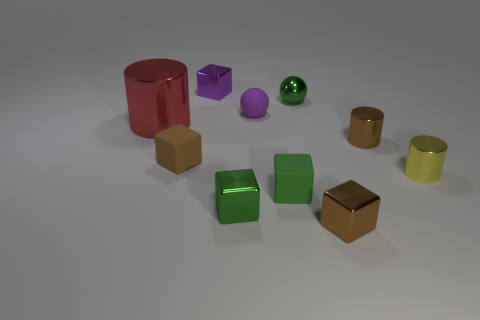There is a big cylinder that is to the left of the yellow shiny thing; are there any small matte objects on the left side of it?
Keep it short and to the point. No. Is there any other thing that is the same material as the tiny yellow cylinder?
Give a very brief answer. Yes. There is a brown matte object; is it the same shape as the green thing behind the small yellow metal object?
Give a very brief answer. No. How many other objects are there of the same size as the yellow shiny thing?
Give a very brief answer. 8. What number of red objects are either large shiny objects or large metallic blocks?
Provide a succinct answer. 1. How many blocks are behind the small green sphere and to the right of the small purple rubber thing?
Your answer should be very brief. 0. What is the brown thing behind the small brown cube that is left of the brown thing that is in front of the brown matte block made of?
Offer a terse response. Metal. What number of small yellow cylinders have the same material as the purple ball?
Offer a very short reply. 0. There is a tiny rubber object that is the same color as the small shiny sphere; what shape is it?
Your answer should be very brief. Cube. What shape is the purple shiny object that is the same size as the purple rubber object?
Provide a short and direct response. Cube. 